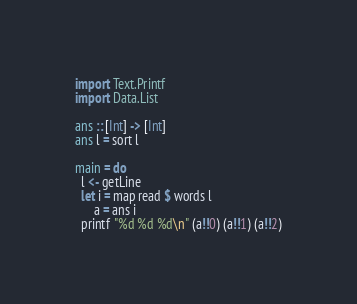<code> <loc_0><loc_0><loc_500><loc_500><_Haskell_>import Text.Printf
import Data.List

ans :: [Int] -> [Int]
ans l = sort l

main = do
  l <- getLine
  let i = map read $ words l
      a = ans i
  printf "%d %d %d\n" (a!!0) (a!!1) (a!!2)</code> 